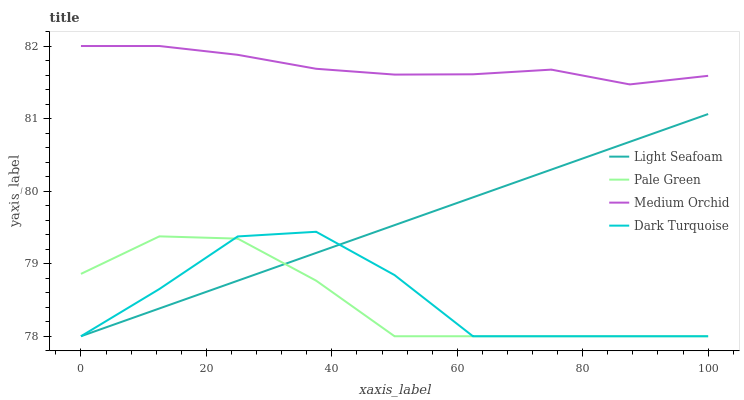Does Pale Green have the minimum area under the curve?
Answer yes or no. Yes. Does Medium Orchid have the maximum area under the curve?
Answer yes or no. Yes. Does Light Seafoam have the minimum area under the curve?
Answer yes or no. No. Does Light Seafoam have the maximum area under the curve?
Answer yes or no. No. Is Light Seafoam the smoothest?
Answer yes or no. Yes. Is Dark Turquoise the roughest?
Answer yes or no. Yes. Is Medium Orchid the smoothest?
Answer yes or no. No. Is Medium Orchid the roughest?
Answer yes or no. No. Does Pale Green have the lowest value?
Answer yes or no. Yes. Does Medium Orchid have the lowest value?
Answer yes or no. No. Does Medium Orchid have the highest value?
Answer yes or no. Yes. Does Light Seafoam have the highest value?
Answer yes or no. No. Is Pale Green less than Medium Orchid?
Answer yes or no. Yes. Is Medium Orchid greater than Dark Turquoise?
Answer yes or no. Yes. Does Pale Green intersect Dark Turquoise?
Answer yes or no. Yes. Is Pale Green less than Dark Turquoise?
Answer yes or no. No. Is Pale Green greater than Dark Turquoise?
Answer yes or no. No. Does Pale Green intersect Medium Orchid?
Answer yes or no. No. 